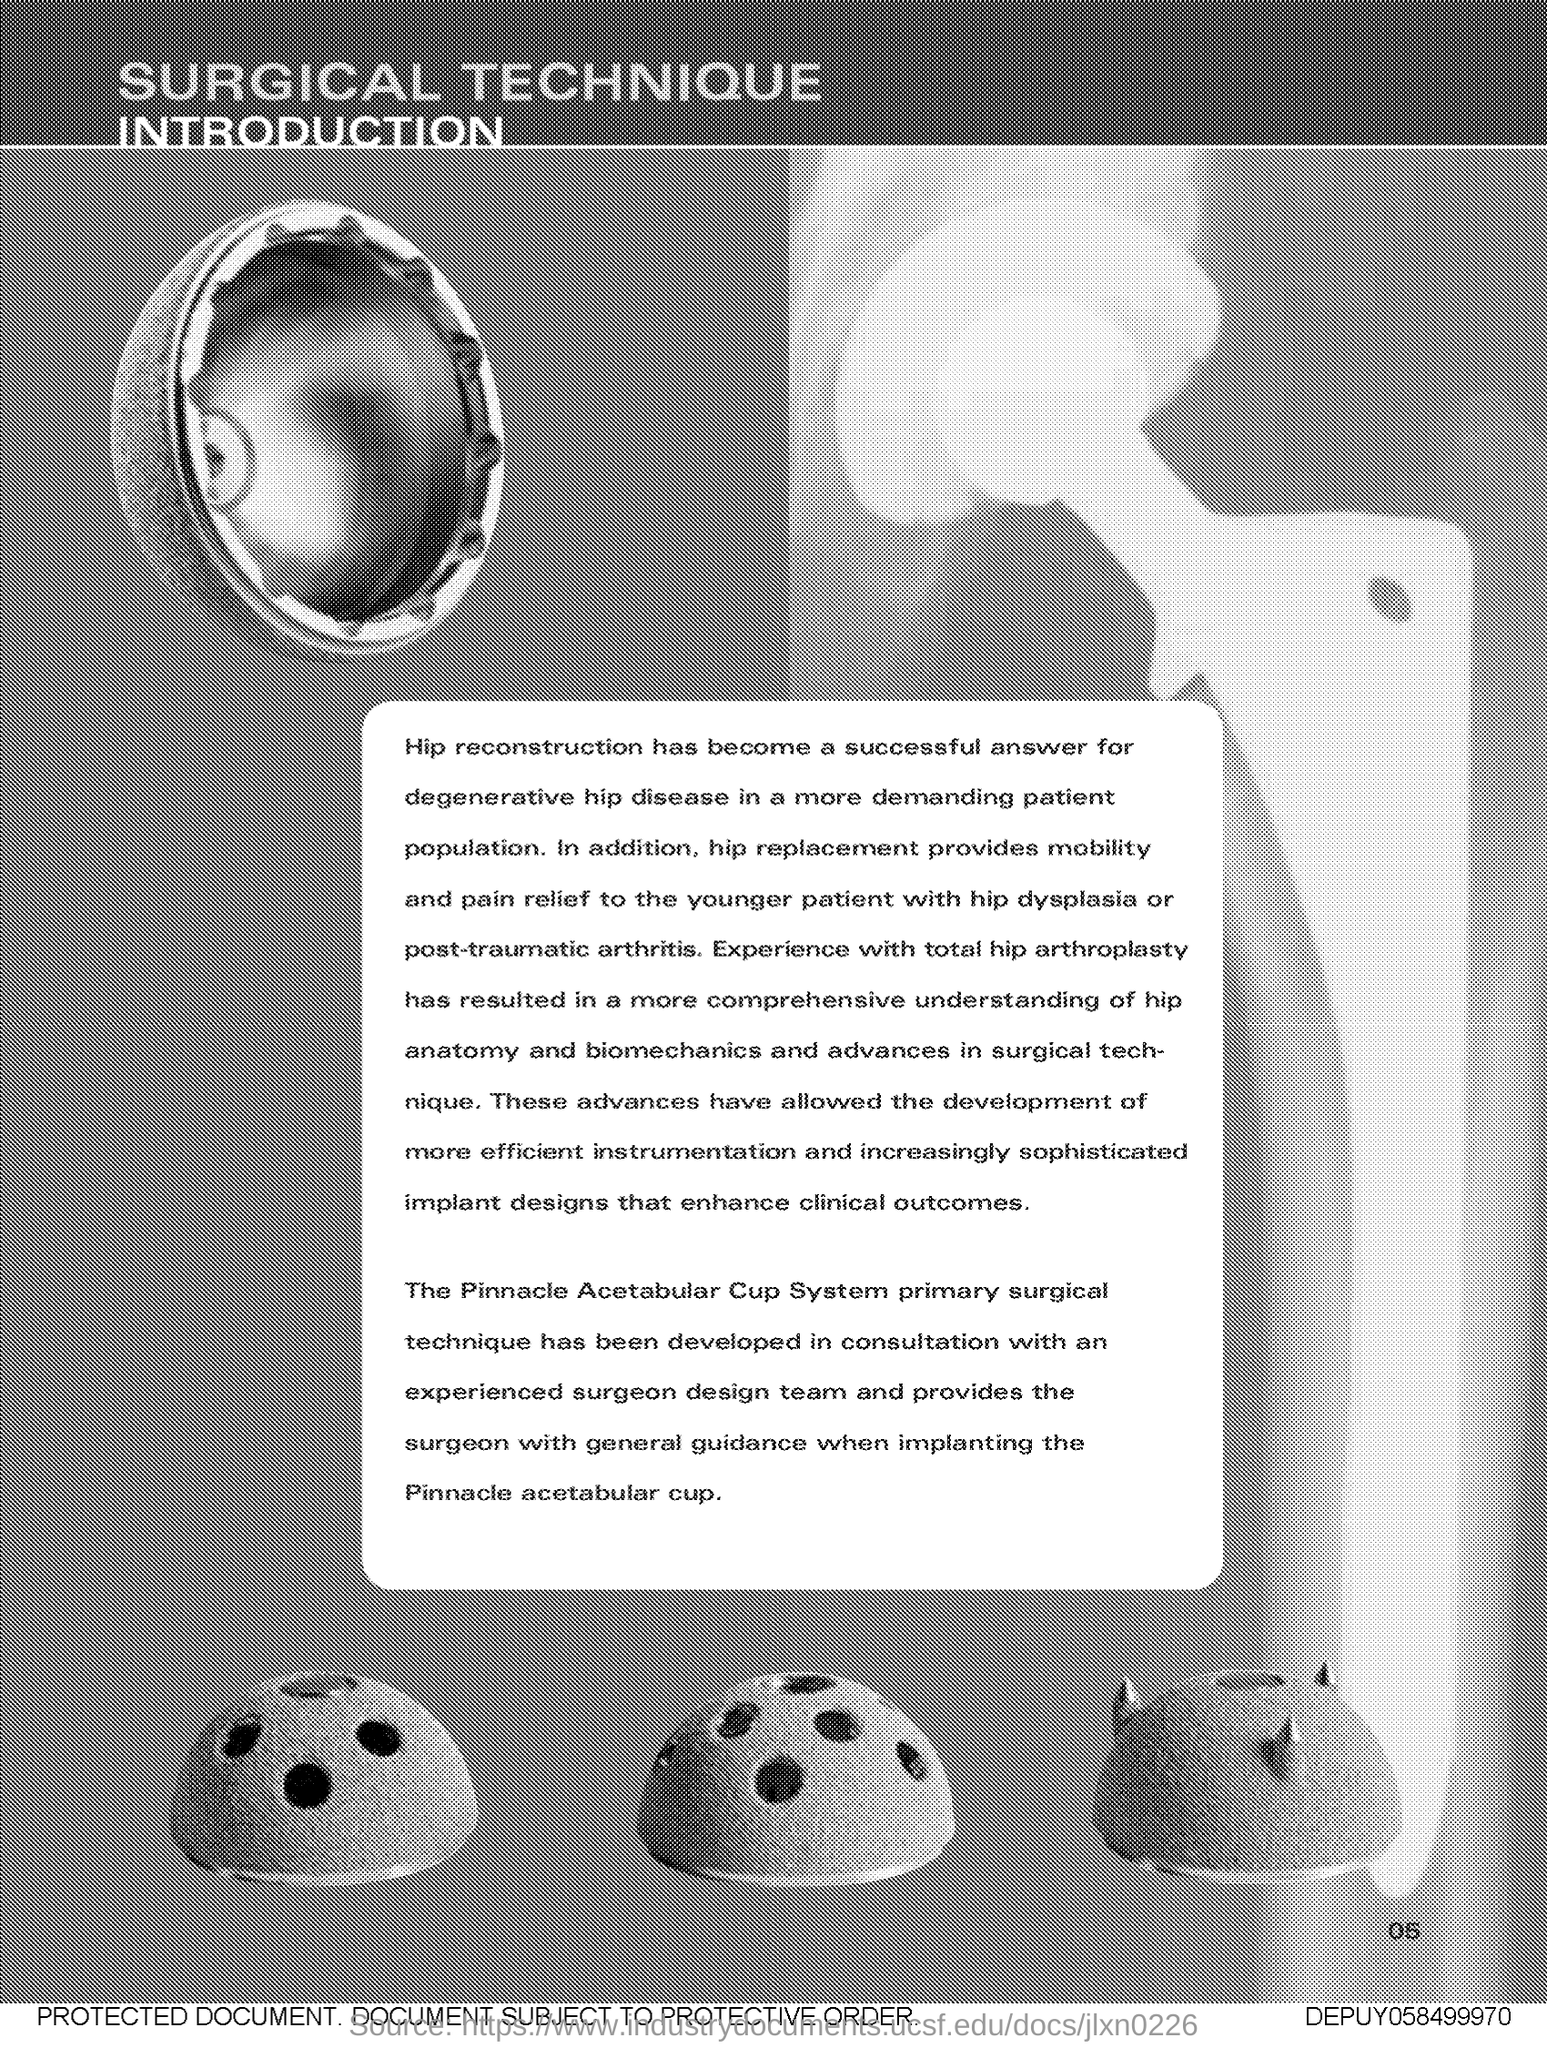What is the title of the document?
Provide a succinct answer. Surgical Technique. What is the successful answer for degenerative hip disease?
Make the answer very short. Hip reconstruction. What provides mobility and pain relief to younger patients with hip dysplasia or post-traumatic arthritis?
Provide a short and direct response. Hip replacement. What was the result of experience with total hip arthroplasty?
Your answer should be compact. A more comprehensive understanding of hip anatomy and biomechanics and advances in surgical technique. 